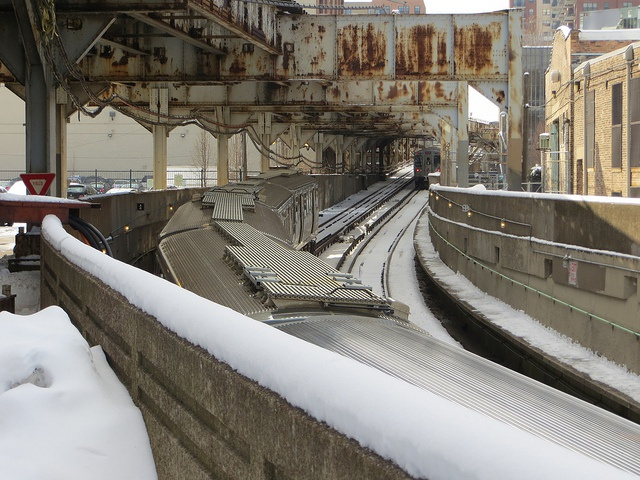Describe the objects in this image and their specific colors. I can see train in black, darkgray, gray, and lightgray tones, train in black and gray tones, and car in black, gray, and darkgray tones in this image. 